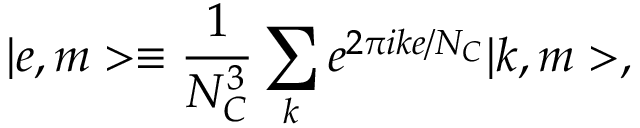<formula> <loc_0><loc_0><loc_500><loc_500>| e , m > \equiv \frac { 1 } { N _ { C } ^ { 3 } } \sum _ { k } e ^ { 2 \pi i k e / N _ { C } } | k , m > ,</formula> 